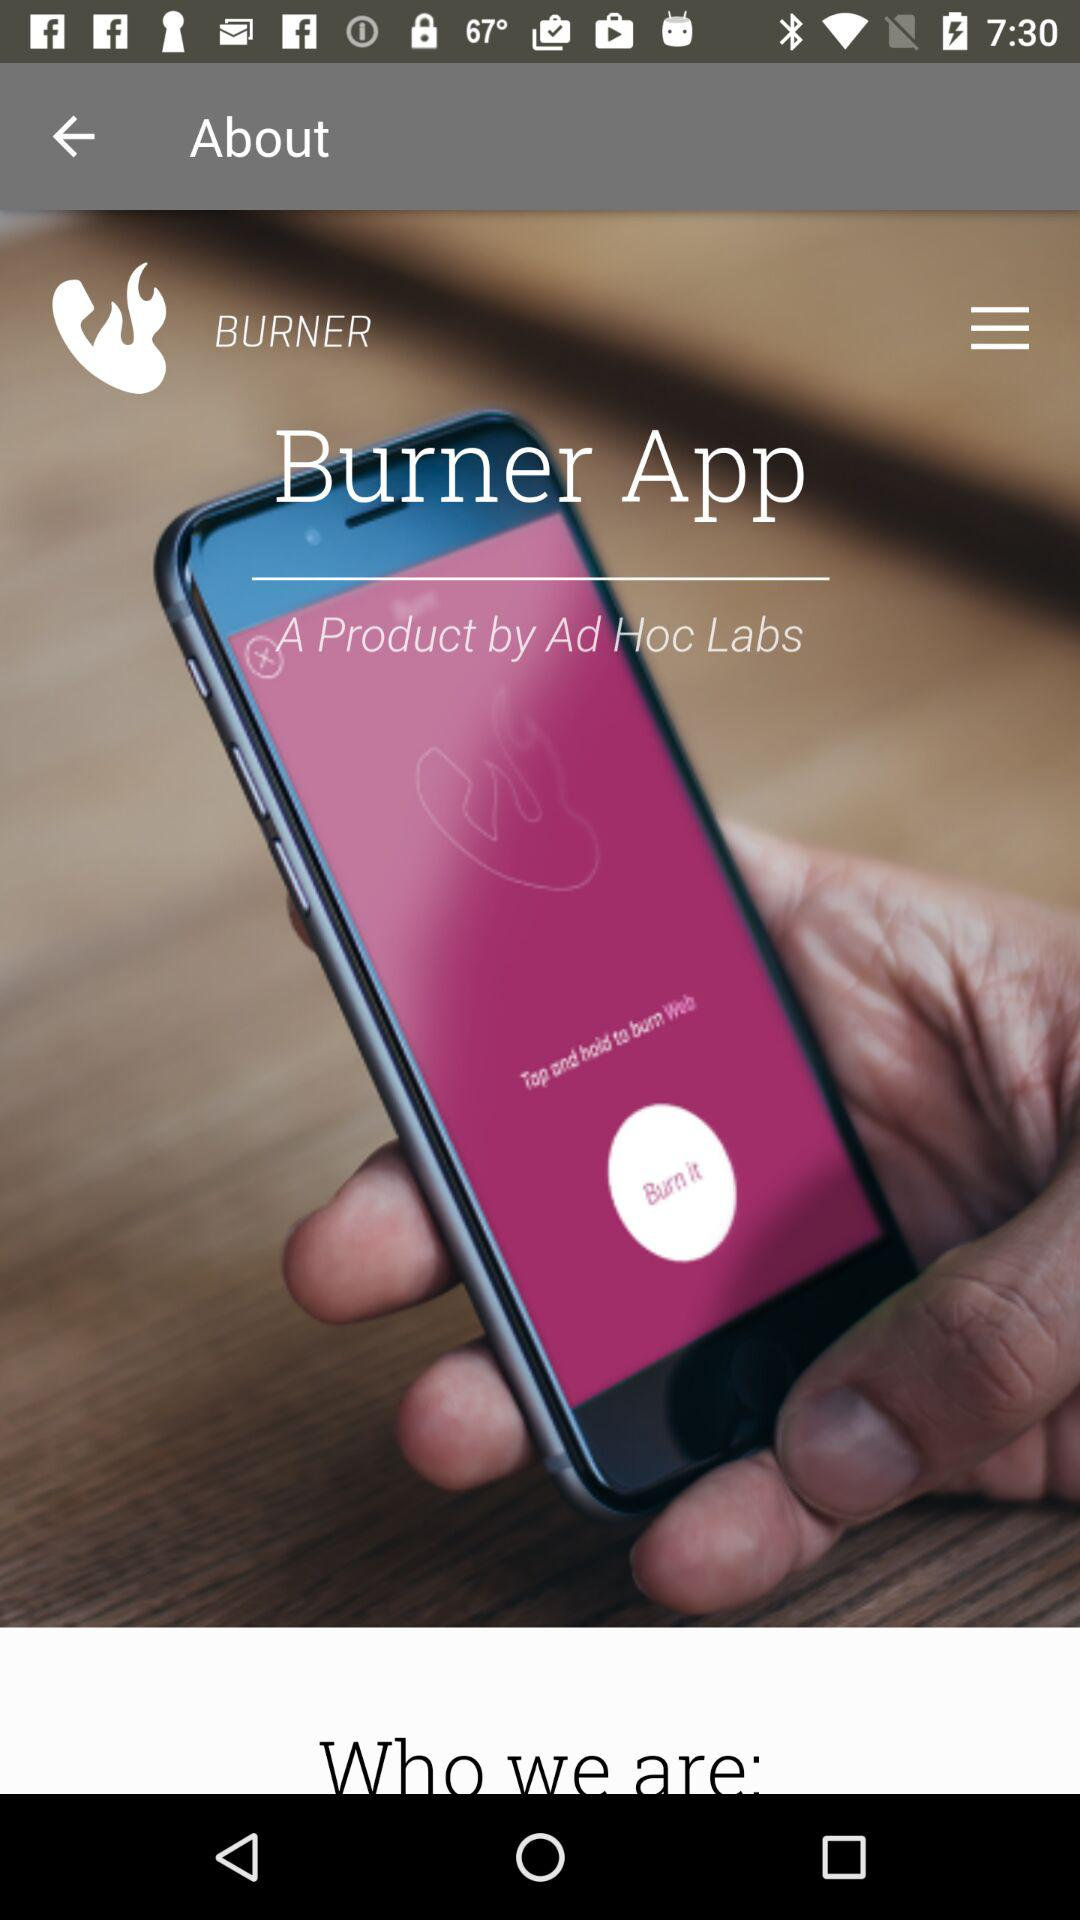What is the app name? The app name is "BURNER". 